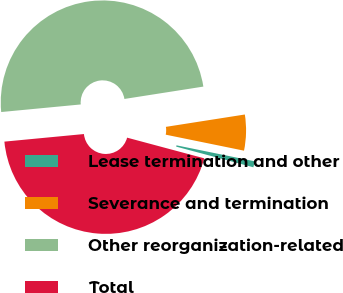Convert chart to OTSL. <chart><loc_0><loc_0><loc_500><loc_500><pie_chart><fcel>Lease termination and other<fcel>Severance and termination<fcel>Other reorganization-related<fcel>Total<nl><fcel>0.96%<fcel>5.68%<fcel>49.04%<fcel>44.32%<nl></chart> 